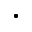Convert formula to latex. <formula><loc_0><loc_0><loc_500><loc_500>.</formula> 